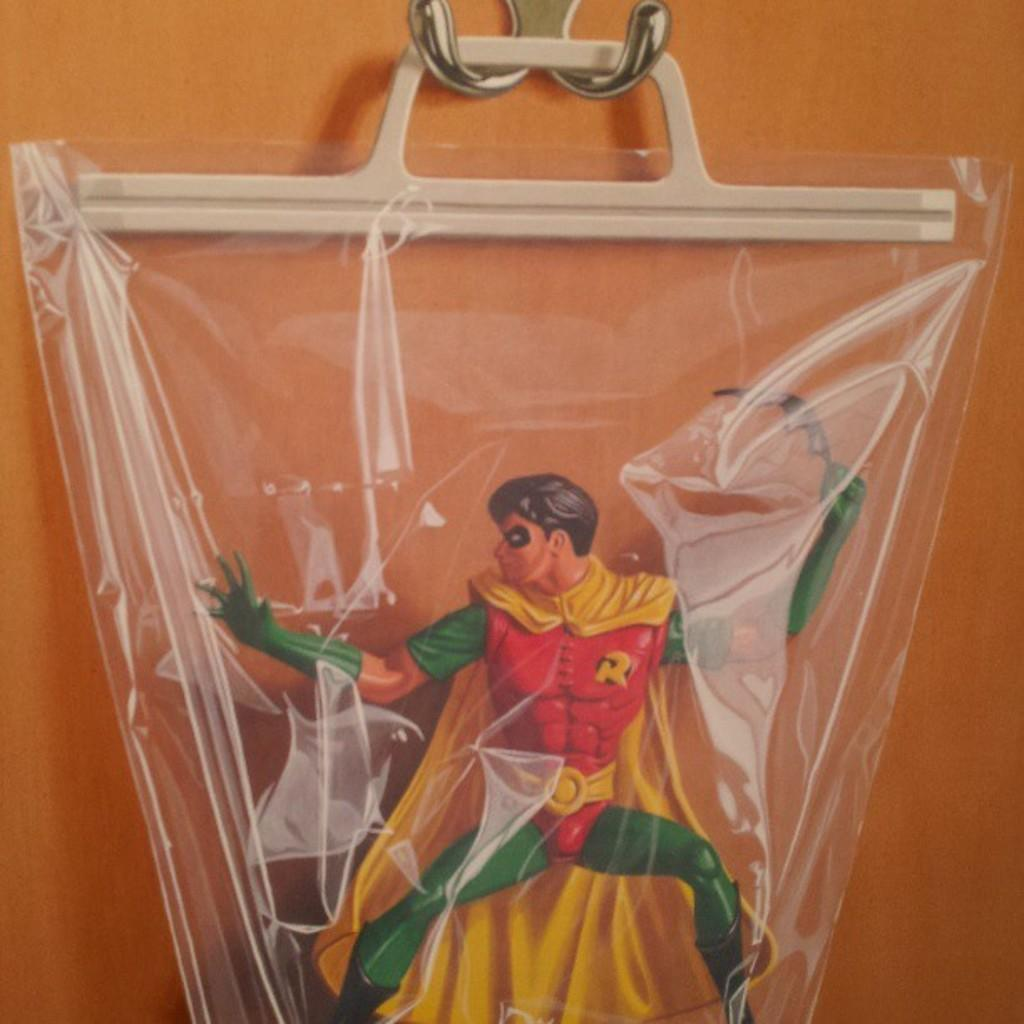What is present on the wall in the image? There is a toy hanging on the wall in the image. Can you describe the wall in the image? The wall is a flat surface with a toy hanging on it. How many rabbits can be seen playing with the toy on the wall in the image? There are no rabbits present in the image; it only features a wall with a toy hanging on it. 